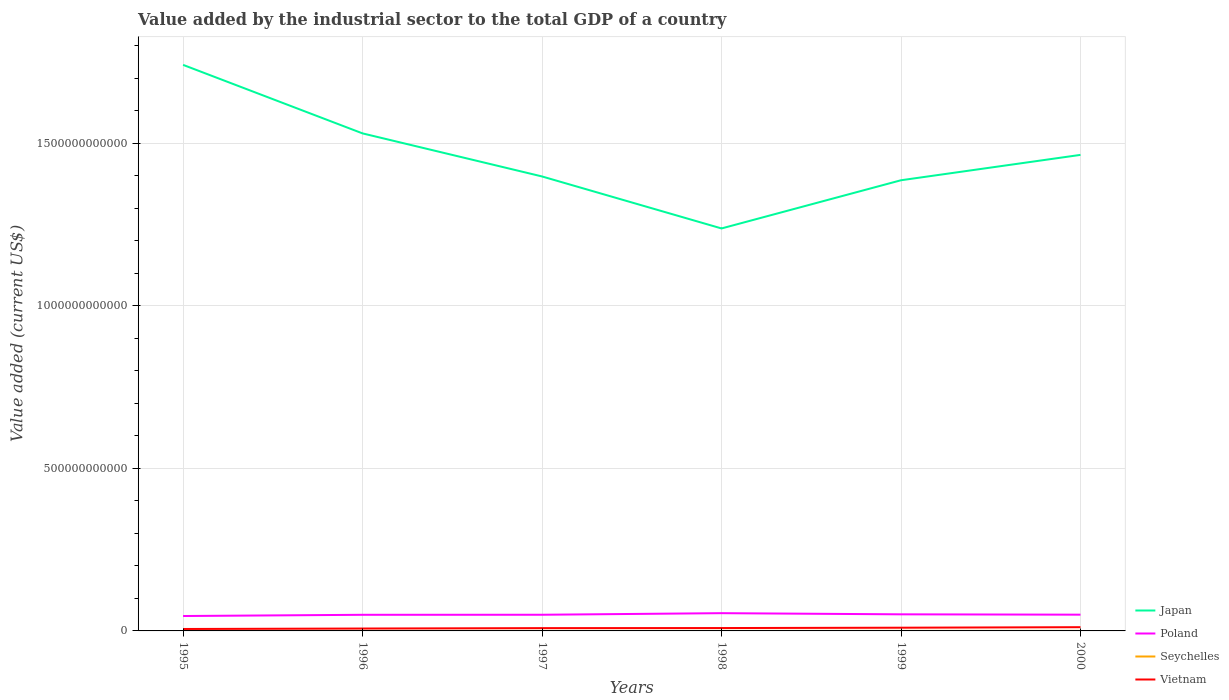How many different coloured lines are there?
Keep it short and to the point. 4. Does the line corresponding to Vietnam intersect with the line corresponding to Poland?
Give a very brief answer. No. Is the number of lines equal to the number of legend labels?
Keep it short and to the point. Yes. Across all years, what is the maximum value added by the industrial sector to the total GDP in Japan?
Your answer should be compact. 1.24e+12. In which year was the value added by the industrial sector to the total GDP in Poland maximum?
Your answer should be very brief. 1995. What is the total value added by the industrial sector to the total GDP in Japan in the graph?
Give a very brief answer. -2.26e+11. What is the difference between the highest and the second highest value added by the industrial sector to the total GDP in Poland?
Your answer should be very brief. 8.75e+09. What is the difference between the highest and the lowest value added by the industrial sector to the total GDP in Seychelles?
Your answer should be very brief. 3. How many lines are there?
Give a very brief answer. 4. What is the difference between two consecutive major ticks on the Y-axis?
Provide a succinct answer. 5.00e+11. Are the values on the major ticks of Y-axis written in scientific E-notation?
Make the answer very short. No. Does the graph contain any zero values?
Offer a terse response. No. Where does the legend appear in the graph?
Ensure brevity in your answer.  Bottom right. What is the title of the graph?
Offer a terse response. Value added by the industrial sector to the total GDP of a country. Does "Upper middle income" appear as one of the legend labels in the graph?
Your answer should be very brief. No. What is the label or title of the Y-axis?
Provide a short and direct response. Value added (current US$). What is the Value added (current US$) in Japan in 1995?
Offer a terse response. 1.74e+12. What is the Value added (current US$) of Poland in 1995?
Give a very brief answer. 4.59e+1. What is the Value added (current US$) of Seychelles in 1995?
Offer a very short reply. 1.15e+08. What is the Value added (current US$) of Vietnam in 1995?
Provide a succinct answer. 5.96e+09. What is the Value added (current US$) in Japan in 1996?
Your response must be concise. 1.53e+12. What is the Value added (current US$) of Poland in 1996?
Your answer should be compact. 4.96e+1. What is the Value added (current US$) of Seychelles in 1996?
Ensure brevity in your answer.  1.19e+08. What is the Value added (current US$) in Vietnam in 1996?
Offer a very short reply. 7.33e+09. What is the Value added (current US$) of Japan in 1997?
Offer a very short reply. 1.40e+12. What is the Value added (current US$) in Poland in 1997?
Ensure brevity in your answer.  4.97e+1. What is the Value added (current US$) in Seychelles in 1997?
Offer a very short reply. 1.37e+08. What is the Value added (current US$) in Vietnam in 1997?
Give a very brief answer. 8.61e+09. What is the Value added (current US$) in Japan in 1998?
Your answer should be very brief. 1.24e+12. What is the Value added (current US$) of Poland in 1998?
Give a very brief answer. 5.46e+1. What is the Value added (current US$) in Seychelles in 1998?
Keep it short and to the point. 1.57e+08. What is the Value added (current US$) in Vietnam in 1998?
Your response must be concise. 8.84e+09. What is the Value added (current US$) in Japan in 1999?
Provide a short and direct response. 1.39e+12. What is the Value added (current US$) in Poland in 1999?
Make the answer very short. 5.10e+1. What is the Value added (current US$) of Seychelles in 1999?
Make the answer very short. 1.69e+08. What is the Value added (current US$) of Vietnam in 1999?
Give a very brief answer. 9.89e+09. What is the Value added (current US$) in Japan in 2000?
Offer a very short reply. 1.46e+12. What is the Value added (current US$) of Poland in 2000?
Your answer should be compact. 5.00e+1. What is the Value added (current US$) in Seychelles in 2000?
Your response must be concise. 1.78e+08. What is the Value added (current US$) of Vietnam in 2000?
Your response must be concise. 1.15e+1. Across all years, what is the maximum Value added (current US$) in Japan?
Offer a terse response. 1.74e+12. Across all years, what is the maximum Value added (current US$) in Poland?
Your answer should be compact. 5.46e+1. Across all years, what is the maximum Value added (current US$) of Seychelles?
Give a very brief answer. 1.78e+08. Across all years, what is the maximum Value added (current US$) in Vietnam?
Keep it short and to the point. 1.15e+1. Across all years, what is the minimum Value added (current US$) of Japan?
Offer a very short reply. 1.24e+12. Across all years, what is the minimum Value added (current US$) of Poland?
Keep it short and to the point. 4.59e+1. Across all years, what is the minimum Value added (current US$) of Seychelles?
Offer a terse response. 1.15e+08. Across all years, what is the minimum Value added (current US$) in Vietnam?
Your answer should be very brief. 5.96e+09. What is the total Value added (current US$) of Japan in the graph?
Your response must be concise. 8.76e+12. What is the total Value added (current US$) in Poland in the graph?
Ensure brevity in your answer.  3.01e+11. What is the total Value added (current US$) of Seychelles in the graph?
Offer a terse response. 8.76e+08. What is the total Value added (current US$) of Vietnam in the graph?
Provide a short and direct response. 5.21e+1. What is the difference between the Value added (current US$) of Japan in 1995 and that in 1996?
Your answer should be very brief. 2.11e+11. What is the difference between the Value added (current US$) of Poland in 1995 and that in 1996?
Keep it short and to the point. -3.73e+09. What is the difference between the Value added (current US$) of Seychelles in 1995 and that in 1996?
Provide a short and direct response. -4.27e+06. What is the difference between the Value added (current US$) in Vietnam in 1995 and that in 1996?
Provide a short and direct response. -1.37e+09. What is the difference between the Value added (current US$) in Japan in 1995 and that in 1997?
Offer a terse response. 3.43e+11. What is the difference between the Value added (current US$) in Poland in 1995 and that in 1997?
Offer a terse response. -3.89e+09. What is the difference between the Value added (current US$) of Seychelles in 1995 and that in 1997?
Ensure brevity in your answer.  -2.19e+07. What is the difference between the Value added (current US$) in Vietnam in 1995 and that in 1997?
Keep it short and to the point. -2.65e+09. What is the difference between the Value added (current US$) in Japan in 1995 and that in 1998?
Ensure brevity in your answer.  5.03e+11. What is the difference between the Value added (current US$) of Poland in 1995 and that in 1998?
Give a very brief answer. -8.75e+09. What is the difference between the Value added (current US$) of Seychelles in 1995 and that in 1998?
Ensure brevity in your answer.  -4.20e+07. What is the difference between the Value added (current US$) of Vietnam in 1995 and that in 1998?
Keep it short and to the point. -2.88e+09. What is the difference between the Value added (current US$) in Japan in 1995 and that in 1999?
Provide a short and direct response. 3.55e+11. What is the difference between the Value added (current US$) in Poland in 1995 and that in 1999?
Your answer should be very brief. -5.16e+09. What is the difference between the Value added (current US$) in Seychelles in 1995 and that in 1999?
Your response must be concise. -5.38e+07. What is the difference between the Value added (current US$) of Vietnam in 1995 and that in 1999?
Offer a terse response. -3.93e+09. What is the difference between the Value added (current US$) of Japan in 1995 and that in 2000?
Make the answer very short. 2.77e+11. What is the difference between the Value added (current US$) of Poland in 1995 and that in 2000?
Your answer should be very brief. -4.13e+09. What is the difference between the Value added (current US$) of Seychelles in 1995 and that in 2000?
Keep it short and to the point. -6.32e+07. What is the difference between the Value added (current US$) in Vietnam in 1995 and that in 2000?
Provide a short and direct response. -5.54e+09. What is the difference between the Value added (current US$) of Japan in 1996 and that in 1997?
Provide a short and direct response. 1.32e+11. What is the difference between the Value added (current US$) in Poland in 1996 and that in 1997?
Your response must be concise. -1.59e+08. What is the difference between the Value added (current US$) of Seychelles in 1996 and that in 1997?
Your answer should be compact. -1.76e+07. What is the difference between the Value added (current US$) in Vietnam in 1996 and that in 1997?
Make the answer very short. -1.28e+09. What is the difference between the Value added (current US$) in Japan in 1996 and that in 1998?
Give a very brief answer. 2.92e+11. What is the difference between the Value added (current US$) in Poland in 1996 and that in 1998?
Provide a succinct answer. -5.02e+09. What is the difference between the Value added (current US$) of Seychelles in 1996 and that in 1998?
Your answer should be very brief. -3.77e+07. What is the difference between the Value added (current US$) in Vietnam in 1996 and that in 1998?
Give a very brief answer. -1.51e+09. What is the difference between the Value added (current US$) of Japan in 1996 and that in 1999?
Your answer should be very brief. 1.44e+11. What is the difference between the Value added (current US$) of Poland in 1996 and that in 1999?
Offer a very short reply. -1.44e+09. What is the difference between the Value added (current US$) of Seychelles in 1996 and that in 1999?
Offer a very short reply. -4.95e+07. What is the difference between the Value added (current US$) in Vietnam in 1996 and that in 1999?
Your response must be concise. -2.56e+09. What is the difference between the Value added (current US$) in Japan in 1996 and that in 2000?
Offer a terse response. 6.61e+1. What is the difference between the Value added (current US$) in Poland in 1996 and that in 2000?
Make the answer very short. -4.02e+08. What is the difference between the Value added (current US$) in Seychelles in 1996 and that in 2000?
Your answer should be very brief. -5.89e+07. What is the difference between the Value added (current US$) in Vietnam in 1996 and that in 2000?
Your response must be concise. -4.17e+09. What is the difference between the Value added (current US$) in Japan in 1997 and that in 1998?
Offer a very short reply. 1.60e+11. What is the difference between the Value added (current US$) of Poland in 1997 and that in 1998?
Offer a very short reply. -4.86e+09. What is the difference between the Value added (current US$) of Seychelles in 1997 and that in 1998?
Your answer should be compact. -2.01e+07. What is the difference between the Value added (current US$) in Vietnam in 1997 and that in 1998?
Keep it short and to the point. -2.31e+08. What is the difference between the Value added (current US$) in Japan in 1997 and that in 1999?
Provide a short and direct response. 1.17e+1. What is the difference between the Value added (current US$) in Poland in 1997 and that in 1999?
Give a very brief answer. -1.28e+09. What is the difference between the Value added (current US$) of Seychelles in 1997 and that in 1999?
Offer a very short reply. -3.19e+07. What is the difference between the Value added (current US$) of Vietnam in 1997 and that in 1999?
Your answer should be very brief. -1.28e+09. What is the difference between the Value added (current US$) in Japan in 1997 and that in 2000?
Offer a terse response. -6.64e+1. What is the difference between the Value added (current US$) of Poland in 1997 and that in 2000?
Offer a terse response. -2.43e+08. What is the difference between the Value added (current US$) of Seychelles in 1997 and that in 2000?
Provide a short and direct response. -4.13e+07. What is the difference between the Value added (current US$) in Vietnam in 1997 and that in 2000?
Provide a short and direct response. -2.89e+09. What is the difference between the Value added (current US$) in Japan in 1998 and that in 1999?
Your response must be concise. -1.48e+11. What is the difference between the Value added (current US$) of Poland in 1998 and that in 1999?
Give a very brief answer. 3.58e+09. What is the difference between the Value added (current US$) in Seychelles in 1998 and that in 1999?
Provide a short and direct response. -1.18e+07. What is the difference between the Value added (current US$) in Vietnam in 1998 and that in 1999?
Your response must be concise. -1.05e+09. What is the difference between the Value added (current US$) of Japan in 1998 and that in 2000?
Offer a very short reply. -2.26e+11. What is the difference between the Value added (current US$) of Poland in 1998 and that in 2000?
Make the answer very short. 4.62e+09. What is the difference between the Value added (current US$) in Seychelles in 1998 and that in 2000?
Ensure brevity in your answer.  -2.12e+07. What is the difference between the Value added (current US$) of Vietnam in 1998 and that in 2000?
Offer a very short reply. -2.66e+09. What is the difference between the Value added (current US$) in Japan in 1999 and that in 2000?
Keep it short and to the point. -7.80e+1. What is the difference between the Value added (current US$) in Poland in 1999 and that in 2000?
Keep it short and to the point. 1.03e+09. What is the difference between the Value added (current US$) in Seychelles in 1999 and that in 2000?
Ensure brevity in your answer.  -9.41e+06. What is the difference between the Value added (current US$) in Vietnam in 1999 and that in 2000?
Offer a very short reply. -1.61e+09. What is the difference between the Value added (current US$) in Japan in 1995 and the Value added (current US$) in Poland in 1996?
Provide a short and direct response. 1.69e+12. What is the difference between the Value added (current US$) of Japan in 1995 and the Value added (current US$) of Seychelles in 1996?
Keep it short and to the point. 1.74e+12. What is the difference between the Value added (current US$) of Japan in 1995 and the Value added (current US$) of Vietnam in 1996?
Provide a short and direct response. 1.73e+12. What is the difference between the Value added (current US$) in Poland in 1995 and the Value added (current US$) in Seychelles in 1996?
Your response must be concise. 4.57e+1. What is the difference between the Value added (current US$) of Poland in 1995 and the Value added (current US$) of Vietnam in 1996?
Give a very brief answer. 3.85e+1. What is the difference between the Value added (current US$) in Seychelles in 1995 and the Value added (current US$) in Vietnam in 1996?
Your response must be concise. -7.22e+09. What is the difference between the Value added (current US$) of Japan in 1995 and the Value added (current US$) of Poland in 1997?
Give a very brief answer. 1.69e+12. What is the difference between the Value added (current US$) in Japan in 1995 and the Value added (current US$) in Seychelles in 1997?
Offer a terse response. 1.74e+12. What is the difference between the Value added (current US$) in Japan in 1995 and the Value added (current US$) in Vietnam in 1997?
Provide a short and direct response. 1.73e+12. What is the difference between the Value added (current US$) in Poland in 1995 and the Value added (current US$) in Seychelles in 1997?
Provide a short and direct response. 4.57e+1. What is the difference between the Value added (current US$) in Poland in 1995 and the Value added (current US$) in Vietnam in 1997?
Make the answer very short. 3.73e+1. What is the difference between the Value added (current US$) in Seychelles in 1995 and the Value added (current US$) in Vietnam in 1997?
Provide a short and direct response. -8.49e+09. What is the difference between the Value added (current US$) of Japan in 1995 and the Value added (current US$) of Poland in 1998?
Make the answer very short. 1.69e+12. What is the difference between the Value added (current US$) in Japan in 1995 and the Value added (current US$) in Seychelles in 1998?
Offer a very short reply. 1.74e+12. What is the difference between the Value added (current US$) in Japan in 1995 and the Value added (current US$) in Vietnam in 1998?
Your answer should be compact. 1.73e+12. What is the difference between the Value added (current US$) of Poland in 1995 and the Value added (current US$) of Seychelles in 1998?
Provide a short and direct response. 4.57e+1. What is the difference between the Value added (current US$) of Poland in 1995 and the Value added (current US$) of Vietnam in 1998?
Give a very brief answer. 3.70e+1. What is the difference between the Value added (current US$) in Seychelles in 1995 and the Value added (current US$) in Vietnam in 1998?
Ensure brevity in your answer.  -8.73e+09. What is the difference between the Value added (current US$) of Japan in 1995 and the Value added (current US$) of Poland in 1999?
Give a very brief answer. 1.69e+12. What is the difference between the Value added (current US$) in Japan in 1995 and the Value added (current US$) in Seychelles in 1999?
Make the answer very short. 1.74e+12. What is the difference between the Value added (current US$) in Japan in 1995 and the Value added (current US$) in Vietnam in 1999?
Offer a very short reply. 1.73e+12. What is the difference between the Value added (current US$) of Poland in 1995 and the Value added (current US$) of Seychelles in 1999?
Your answer should be compact. 4.57e+1. What is the difference between the Value added (current US$) in Poland in 1995 and the Value added (current US$) in Vietnam in 1999?
Your response must be concise. 3.60e+1. What is the difference between the Value added (current US$) in Seychelles in 1995 and the Value added (current US$) in Vietnam in 1999?
Your response must be concise. -9.78e+09. What is the difference between the Value added (current US$) in Japan in 1995 and the Value added (current US$) in Poland in 2000?
Give a very brief answer. 1.69e+12. What is the difference between the Value added (current US$) of Japan in 1995 and the Value added (current US$) of Seychelles in 2000?
Your response must be concise. 1.74e+12. What is the difference between the Value added (current US$) in Japan in 1995 and the Value added (current US$) in Vietnam in 2000?
Your response must be concise. 1.73e+12. What is the difference between the Value added (current US$) of Poland in 1995 and the Value added (current US$) of Seychelles in 2000?
Provide a short and direct response. 4.57e+1. What is the difference between the Value added (current US$) of Poland in 1995 and the Value added (current US$) of Vietnam in 2000?
Offer a very short reply. 3.44e+1. What is the difference between the Value added (current US$) of Seychelles in 1995 and the Value added (current US$) of Vietnam in 2000?
Your response must be concise. -1.14e+1. What is the difference between the Value added (current US$) in Japan in 1996 and the Value added (current US$) in Poland in 1997?
Offer a very short reply. 1.48e+12. What is the difference between the Value added (current US$) of Japan in 1996 and the Value added (current US$) of Seychelles in 1997?
Your answer should be very brief. 1.53e+12. What is the difference between the Value added (current US$) of Japan in 1996 and the Value added (current US$) of Vietnam in 1997?
Provide a short and direct response. 1.52e+12. What is the difference between the Value added (current US$) in Poland in 1996 and the Value added (current US$) in Seychelles in 1997?
Provide a succinct answer. 4.95e+1. What is the difference between the Value added (current US$) of Poland in 1996 and the Value added (current US$) of Vietnam in 1997?
Ensure brevity in your answer.  4.10e+1. What is the difference between the Value added (current US$) in Seychelles in 1996 and the Value added (current US$) in Vietnam in 1997?
Provide a succinct answer. -8.49e+09. What is the difference between the Value added (current US$) in Japan in 1996 and the Value added (current US$) in Poland in 1998?
Provide a succinct answer. 1.48e+12. What is the difference between the Value added (current US$) of Japan in 1996 and the Value added (current US$) of Seychelles in 1998?
Provide a short and direct response. 1.53e+12. What is the difference between the Value added (current US$) of Japan in 1996 and the Value added (current US$) of Vietnam in 1998?
Offer a very short reply. 1.52e+12. What is the difference between the Value added (current US$) of Poland in 1996 and the Value added (current US$) of Seychelles in 1998?
Provide a short and direct response. 4.94e+1. What is the difference between the Value added (current US$) in Poland in 1996 and the Value added (current US$) in Vietnam in 1998?
Offer a terse response. 4.07e+1. What is the difference between the Value added (current US$) in Seychelles in 1996 and the Value added (current US$) in Vietnam in 1998?
Make the answer very short. -8.72e+09. What is the difference between the Value added (current US$) of Japan in 1996 and the Value added (current US$) of Poland in 1999?
Your response must be concise. 1.48e+12. What is the difference between the Value added (current US$) in Japan in 1996 and the Value added (current US$) in Seychelles in 1999?
Offer a very short reply. 1.53e+12. What is the difference between the Value added (current US$) in Japan in 1996 and the Value added (current US$) in Vietnam in 1999?
Your answer should be compact. 1.52e+12. What is the difference between the Value added (current US$) of Poland in 1996 and the Value added (current US$) of Seychelles in 1999?
Provide a succinct answer. 4.94e+1. What is the difference between the Value added (current US$) of Poland in 1996 and the Value added (current US$) of Vietnam in 1999?
Make the answer very short. 3.97e+1. What is the difference between the Value added (current US$) in Seychelles in 1996 and the Value added (current US$) in Vietnam in 1999?
Give a very brief answer. -9.77e+09. What is the difference between the Value added (current US$) of Japan in 1996 and the Value added (current US$) of Poland in 2000?
Your answer should be very brief. 1.48e+12. What is the difference between the Value added (current US$) of Japan in 1996 and the Value added (current US$) of Seychelles in 2000?
Provide a short and direct response. 1.53e+12. What is the difference between the Value added (current US$) in Japan in 1996 and the Value added (current US$) in Vietnam in 2000?
Make the answer very short. 1.52e+12. What is the difference between the Value added (current US$) of Poland in 1996 and the Value added (current US$) of Seychelles in 2000?
Provide a succinct answer. 4.94e+1. What is the difference between the Value added (current US$) of Poland in 1996 and the Value added (current US$) of Vietnam in 2000?
Offer a very short reply. 3.81e+1. What is the difference between the Value added (current US$) in Seychelles in 1996 and the Value added (current US$) in Vietnam in 2000?
Give a very brief answer. -1.14e+1. What is the difference between the Value added (current US$) of Japan in 1997 and the Value added (current US$) of Poland in 1998?
Ensure brevity in your answer.  1.34e+12. What is the difference between the Value added (current US$) in Japan in 1997 and the Value added (current US$) in Seychelles in 1998?
Give a very brief answer. 1.40e+12. What is the difference between the Value added (current US$) in Japan in 1997 and the Value added (current US$) in Vietnam in 1998?
Give a very brief answer. 1.39e+12. What is the difference between the Value added (current US$) in Poland in 1997 and the Value added (current US$) in Seychelles in 1998?
Offer a terse response. 4.96e+1. What is the difference between the Value added (current US$) of Poland in 1997 and the Value added (current US$) of Vietnam in 1998?
Provide a succinct answer. 4.09e+1. What is the difference between the Value added (current US$) of Seychelles in 1997 and the Value added (current US$) of Vietnam in 1998?
Your response must be concise. -8.70e+09. What is the difference between the Value added (current US$) in Japan in 1997 and the Value added (current US$) in Poland in 1999?
Ensure brevity in your answer.  1.35e+12. What is the difference between the Value added (current US$) of Japan in 1997 and the Value added (current US$) of Seychelles in 1999?
Provide a short and direct response. 1.40e+12. What is the difference between the Value added (current US$) of Japan in 1997 and the Value added (current US$) of Vietnam in 1999?
Give a very brief answer. 1.39e+12. What is the difference between the Value added (current US$) of Poland in 1997 and the Value added (current US$) of Seychelles in 1999?
Your answer should be very brief. 4.96e+1. What is the difference between the Value added (current US$) in Poland in 1997 and the Value added (current US$) in Vietnam in 1999?
Your response must be concise. 3.99e+1. What is the difference between the Value added (current US$) of Seychelles in 1997 and the Value added (current US$) of Vietnam in 1999?
Give a very brief answer. -9.76e+09. What is the difference between the Value added (current US$) of Japan in 1997 and the Value added (current US$) of Poland in 2000?
Keep it short and to the point. 1.35e+12. What is the difference between the Value added (current US$) of Japan in 1997 and the Value added (current US$) of Seychelles in 2000?
Provide a succinct answer. 1.40e+12. What is the difference between the Value added (current US$) in Japan in 1997 and the Value added (current US$) in Vietnam in 2000?
Make the answer very short. 1.39e+12. What is the difference between the Value added (current US$) in Poland in 1997 and the Value added (current US$) in Seychelles in 2000?
Your answer should be very brief. 4.96e+1. What is the difference between the Value added (current US$) of Poland in 1997 and the Value added (current US$) of Vietnam in 2000?
Give a very brief answer. 3.82e+1. What is the difference between the Value added (current US$) in Seychelles in 1997 and the Value added (current US$) in Vietnam in 2000?
Offer a terse response. -1.14e+1. What is the difference between the Value added (current US$) in Japan in 1998 and the Value added (current US$) in Poland in 1999?
Provide a short and direct response. 1.19e+12. What is the difference between the Value added (current US$) in Japan in 1998 and the Value added (current US$) in Seychelles in 1999?
Offer a terse response. 1.24e+12. What is the difference between the Value added (current US$) of Japan in 1998 and the Value added (current US$) of Vietnam in 1999?
Ensure brevity in your answer.  1.23e+12. What is the difference between the Value added (current US$) in Poland in 1998 and the Value added (current US$) in Seychelles in 1999?
Your response must be concise. 5.44e+1. What is the difference between the Value added (current US$) of Poland in 1998 and the Value added (current US$) of Vietnam in 1999?
Make the answer very short. 4.47e+1. What is the difference between the Value added (current US$) in Seychelles in 1998 and the Value added (current US$) in Vietnam in 1999?
Provide a succinct answer. -9.74e+09. What is the difference between the Value added (current US$) of Japan in 1998 and the Value added (current US$) of Poland in 2000?
Give a very brief answer. 1.19e+12. What is the difference between the Value added (current US$) of Japan in 1998 and the Value added (current US$) of Seychelles in 2000?
Ensure brevity in your answer.  1.24e+12. What is the difference between the Value added (current US$) in Japan in 1998 and the Value added (current US$) in Vietnam in 2000?
Provide a short and direct response. 1.23e+12. What is the difference between the Value added (current US$) of Poland in 1998 and the Value added (current US$) of Seychelles in 2000?
Offer a terse response. 5.44e+1. What is the difference between the Value added (current US$) in Poland in 1998 and the Value added (current US$) in Vietnam in 2000?
Give a very brief answer. 4.31e+1. What is the difference between the Value added (current US$) in Seychelles in 1998 and the Value added (current US$) in Vietnam in 2000?
Give a very brief answer. -1.13e+1. What is the difference between the Value added (current US$) in Japan in 1999 and the Value added (current US$) in Poland in 2000?
Your answer should be very brief. 1.34e+12. What is the difference between the Value added (current US$) of Japan in 1999 and the Value added (current US$) of Seychelles in 2000?
Ensure brevity in your answer.  1.39e+12. What is the difference between the Value added (current US$) in Japan in 1999 and the Value added (current US$) in Vietnam in 2000?
Offer a very short reply. 1.37e+12. What is the difference between the Value added (current US$) of Poland in 1999 and the Value added (current US$) of Seychelles in 2000?
Provide a short and direct response. 5.08e+1. What is the difference between the Value added (current US$) in Poland in 1999 and the Value added (current US$) in Vietnam in 2000?
Provide a succinct answer. 3.95e+1. What is the difference between the Value added (current US$) of Seychelles in 1999 and the Value added (current US$) of Vietnam in 2000?
Keep it short and to the point. -1.13e+1. What is the average Value added (current US$) of Japan per year?
Provide a succinct answer. 1.46e+12. What is the average Value added (current US$) in Poland per year?
Offer a terse response. 5.01e+1. What is the average Value added (current US$) in Seychelles per year?
Your answer should be very brief. 1.46e+08. What is the average Value added (current US$) of Vietnam per year?
Offer a terse response. 8.69e+09. In the year 1995, what is the difference between the Value added (current US$) in Japan and Value added (current US$) in Poland?
Provide a succinct answer. 1.70e+12. In the year 1995, what is the difference between the Value added (current US$) of Japan and Value added (current US$) of Seychelles?
Ensure brevity in your answer.  1.74e+12. In the year 1995, what is the difference between the Value added (current US$) in Japan and Value added (current US$) in Vietnam?
Make the answer very short. 1.74e+12. In the year 1995, what is the difference between the Value added (current US$) in Poland and Value added (current US$) in Seychelles?
Provide a succinct answer. 4.57e+1. In the year 1995, what is the difference between the Value added (current US$) of Poland and Value added (current US$) of Vietnam?
Give a very brief answer. 3.99e+1. In the year 1995, what is the difference between the Value added (current US$) in Seychelles and Value added (current US$) in Vietnam?
Make the answer very short. -5.85e+09. In the year 1996, what is the difference between the Value added (current US$) of Japan and Value added (current US$) of Poland?
Make the answer very short. 1.48e+12. In the year 1996, what is the difference between the Value added (current US$) of Japan and Value added (current US$) of Seychelles?
Keep it short and to the point. 1.53e+12. In the year 1996, what is the difference between the Value added (current US$) in Japan and Value added (current US$) in Vietnam?
Your response must be concise. 1.52e+12. In the year 1996, what is the difference between the Value added (current US$) of Poland and Value added (current US$) of Seychelles?
Provide a succinct answer. 4.95e+1. In the year 1996, what is the difference between the Value added (current US$) in Poland and Value added (current US$) in Vietnam?
Provide a short and direct response. 4.23e+1. In the year 1996, what is the difference between the Value added (current US$) of Seychelles and Value added (current US$) of Vietnam?
Your response must be concise. -7.21e+09. In the year 1997, what is the difference between the Value added (current US$) in Japan and Value added (current US$) in Poland?
Keep it short and to the point. 1.35e+12. In the year 1997, what is the difference between the Value added (current US$) in Japan and Value added (current US$) in Seychelles?
Your answer should be very brief. 1.40e+12. In the year 1997, what is the difference between the Value added (current US$) in Japan and Value added (current US$) in Vietnam?
Ensure brevity in your answer.  1.39e+12. In the year 1997, what is the difference between the Value added (current US$) of Poland and Value added (current US$) of Seychelles?
Provide a succinct answer. 4.96e+1. In the year 1997, what is the difference between the Value added (current US$) of Poland and Value added (current US$) of Vietnam?
Your answer should be compact. 4.11e+1. In the year 1997, what is the difference between the Value added (current US$) in Seychelles and Value added (current US$) in Vietnam?
Your response must be concise. -8.47e+09. In the year 1998, what is the difference between the Value added (current US$) in Japan and Value added (current US$) in Poland?
Ensure brevity in your answer.  1.18e+12. In the year 1998, what is the difference between the Value added (current US$) of Japan and Value added (current US$) of Seychelles?
Your response must be concise. 1.24e+12. In the year 1998, what is the difference between the Value added (current US$) of Japan and Value added (current US$) of Vietnam?
Offer a very short reply. 1.23e+12. In the year 1998, what is the difference between the Value added (current US$) in Poland and Value added (current US$) in Seychelles?
Your answer should be very brief. 5.45e+1. In the year 1998, what is the difference between the Value added (current US$) in Poland and Value added (current US$) in Vietnam?
Make the answer very short. 4.58e+1. In the year 1998, what is the difference between the Value added (current US$) of Seychelles and Value added (current US$) of Vietnam?
Your response must be concise. -8.68e+09. In the year 1999, what is the difference between the Value added (current US$) in Japan and Value added (current US$) in Poland?
Make the answer very short. 1.34e+12. In the year 1999, what is the difference between the Value added (current US$) in Japan and Value added (current US$) in Seychelles?
Provide a succinct answer. 1.39e+12. In the year 1999, what is the difference between the Value added (current US$) in Japan and Value added (current US$) in Vietnam?
Offer a terse response. 1.38e+12. In the year 1999, what is the difference between the Value added (current US$) in Poland and Value added (current US$) in Seychelles?
Your response must be concise. 5.09e+1. In the year 1999, what is the difference between the Value added (current US$) of Poland and Value added (current US$) of Vietnam?
Give a very brief answer. 4.11e+1. In the year 1999, what is the difference between the Value added (current US$) in Seychelles and Value added (current US$) in Vietnam?
Provide a succinct answer. -9.73e+09. In the year 2000, what is the difference between the Value added (current US$) in Japan and Value added (current US$) in Poland?
Give a very brief answer. 1.41e+12. In the year 2000, what is the difference between the Value added (current US$) in Japan and Value added (current US$) in Seychelles?
Provide a short and direct response. 1.46e+12. In the year 2000, what is the difference between the Value added (current US$) in Japan and Value added (current US$) in Vietnam?
Give a very brief answer. 1.45e+12. In the year 2000, what is the difference between the Value added (current US$) in Poland and Value added (current US$) in Seychelles?
Your response must be concise. 4.98e+1. In the year 2000, what is the difference between the Value added (current US$) in Poland and Value added (current US$) in Vietnam?
Your response must be concise. 3.85e+1. In the year 2000, what is the difference between the Value added (current US$) of Seychelles and Value added (current US$) of Vietnam?
Provide a succinct answer. -1.13e+1. What is the ratio of the Value added (current US$) of Japan in 1995 to that in 1996?
Your answer should be compact. 1.14. What is the ratio of the Value added (current US$) of Poland in 1995 to that in 1996?
Your answer should be very brief. 0.92. What is the ratio of the Value added (current US$) in Seychelles in 1995 to that in 1996?
Make the answer very short. 0.96. What is the ratio of the Value added (current US$) of Vietnam in 1995 to that in 1996?
Your answer should be compact. 0.81. What is the ratio of the Value added (current US$) in Japan in 1995 to that in 1997?
Offer a terse response. 1.25. What is the ratio of the Value added (current US$) in Poland in 1995 to that in 1997?
Offer a very short reply. 0.92. What is the ratio of the Value added (current US$) in Seychelles in 1995 to that in 1997?
Your answer should be compact. 0.84. What is the ratio of the Value added (current US$) in Vietnam in 1995 to that in 1997?
Offer a terse response. 0.69. What is the ratio of the Value added (current US$) of Japan in 1995 to that in 1998?
Provide a succinct answer. 1.41. What is the ratio of the Value added (current US$) in Poland in 1995 to that in 1998?
Offer a terse response. 0.84. What is the ratio of the Value added (current US$) of Seychelles in 1995 to that in 1998?
Your answer should be compact. 0.73. What is the ratio of the Value added (current US$) in Vietnam in 1995 to that in 1998?
Ensure brevity in your answer.  0.67. What is the ratio of the Value added (current US$) in Japan in 1995 to that in 1999?
Keep it short and to the point. 1.26. What is the ratio of the Value added (current US$) in Poland in 1995 to that in 1999?
Your answer should be very brief. 0.9. What is the ratio of the Value added (current US$) in Seychelles in 1995 to that in 1999?
Give a very brief answer. 0.68. What is the ratio of the Value added (current US$) of Vietnam in 1995 to that in 1999?
Provide a succinct answer. 0.6. What is the ratio of the Value added (current US$) in Japan in 1995 to that in 2000?
Give a very brief answer. 1.19. What is the ratio of the Value added (current US$) of Poland in 1995 to that in 2000?
Make the answer very short. 0.92. What is the ratio of the Value added (current US$) in Seychelles in 1995 to that in 2000?
Your answer should be very brief. 0.65. What is the ratio of the Value added (current US$) of Vietnam in 1995 to that in 2000?
Give a very brief answer. 0.52. What is the ratio of the Value added (current US$) in Japan in 1996 to that in 1997?
Offer a very short reply. 1.09. What is the ratio of the Value added (current US$) of Poland in 1996 to that in 1997?
Provide a succinct answer. 1. What is the ratio of the Value added (current US$) in Seychelles in 1996 to that in 1997?
Give a very brief answer. 0.87. What is the ratio of the Value added (current US$) of Vietnam in 1996 to that in 1997?
Provide a succinct answer. 0.85. What is the ratio of the Value added (current US$) in Japan in 1996 to that in 1998?
Your response must be concise. 1.24. What is the ratio of the Value added (current US$) of Poland in 1996 to that in 1998?
Your response must be concise. 0.91. What is the ratio of the Value added (current US$) of Seychelles in 1996 to that in 1998?
Give a very brief answer. 0.76. What is the ratio of the Value added (current US$) in Vietnam in 1996 to that in 1998?
Keep it short and to the point. 0.83. What is the ratio of the Value added (current US$) in Japan in 1996 to that in 1999?
Your answer should be very brief. 1.1. What is the ratio of the Value added (current US$) in Poland in 1996 to that in 1999?
Offer a terse response. 0.97. What is the ratio of the Value added (current US$) of Seychelles in 1996 to that in 1999?
Offer a very short reply. 0.71. What is the ratio of the Value added (current US$) in Vietnam in 1996 to that in 1999?
Your answer should be very brief. 0.74. What is the ratio of the Value added (current US$) of Japan in 1996 to that in 2000?
Your response must be concise. 1.05. What is the ratio of the Value added (current US$) in Poland in 1996 to that in 2000?
Offer a terse response. 0.99. What is the ratio of the Value added (current US$) of Seychelles in 1996 to that in 2000?
Your answer should be compact. 0.67. What is the ratio of the Value added (current US$) of Vietnam in 1996 to that in 2000?
Make the answer very short. 0.64. What is the ratio of the Value added (current US$) in Japan in 1997 to that in 1998?
Your response must be concise. 1.13. What is the ratio of the Value added (current US$) of Poland in 1997 to that in 1998?
Make the answer very short. 0.91. What is the ratio of the Value added (current US$) in Seychelles in 1997 to that in 1998?
Your response must be concise. 0.87. What is the ratio of the Value added (current US$) of Vietnam in 1997 to that in 1998?
Make the answer very short. 0.97. What is the ratio of the Value added (current US$) of Japan in 1997 to that in 1999?
Your answer should be compact. 1.01. What is the ratio of the Value added (current US$) in Poland in 1997 to that in 1999?
Your answer should be compact. 0.97. What is the ratio of the Value added (current US$) in Seychelles in 1997 to that in 1999?
Provide a short and direct response. 0.81. What is the ratio of the Value added (current US$) in Vietnam in 1997 to that in 1999?
Make the answer very short. 0.87. What is the ratio of the Value added (current US$) in Japan in 1997 to that in 2000?
Give a very brief answer. 0.95. What is the ratio of the Value added (current US$) of Seychelles in 1997 to that in 2000?
Your response must be concise. 0.77. What is the ratio of the Value added (current US$) of Vietnam in 1997 to that in 2000?
Provide a short and direct response. 0.75. What is the ratio of the Value added (current US$) of Japan in 1998 to that in 1999?
Ensure brevity in your answer.  0.89. What is the ratio of the Value added (current US$) of Poland in 1998 to that in 1999?
Offer a terse response. 1.07. What is the ratio of the Value added (current US$) of Seychelles in 1998 to that in 1999?
Provide a short and direct response. 0.93. What is the ratio of the Value added (current US$) of Vietnam in 1998 to that in 1999?
Offer a very short reply. 0.89. What is the ratio of the Value added (current US$) in Japan in 1998 to that in 2000?
Provide a short and direct response. 0.85. What is the ratio of the Value added (current US$) of Poland in 1998 to that in 2000?
Your answer should be very brief. 1.09. What is the ratio of the Value added (current US$) in Seychelles in 1998 to that in 2000?
Make the answer very short. 0.88. What is the ratio of the Value added (current US$) of Vietnam in 1998 to that in 2000?
Offer a terse response. 0.77. What is the ratio of the Value added (current US$) in Japan in 1999 to that in 2000?
Provide a short and direct response. 0.95. What is the ratio of the Value added (current US$) in Poland in 1999 to that in 2000?
Provide a short and direct response. 1.02. What is the ratio of the Value added (current US$) in Seychelles in 1999 to that in 2000?
Offer a very short reply. 0.95. What is the ratio of the Value added (current US$) of Vietnam in 1999 to that in 2000?
Make the answer very short. 0.86. What is the difference between the highest and the second highest Value added (current US$) in Japan?
Provide a short and direct response. 2.11e+11. What is the difference between the highest and the second highest Value added (current US$) of Poland?
Your response must be concise. 3.58e+09. What is the difference between the highest and the second highest Value added (current US$) in Seychelles?
Offer a terse response. 9.41e+06. What is the difference between the highest and the second highest Value added (current US$) in Vietnam?
Keep it short and to the point. 1.61e+09. What is the difference between the highest and the lowest Value added (current US$) in Japan?
Provide a short and direct response. 5.03e+11. What is the difference between the highest and the lowest Value added (current US$) of Poland?
Keep it short and to the point. 8.75e+09. What is the difference between the highest and the lowest Value added (current US$) of Seychelles?
Your response must be concise. 6.32e+07. What is the difference between the highest and the lowest Value added (current US$) in Vietnam?
Your answer should be very brief. 5.54e+09. 